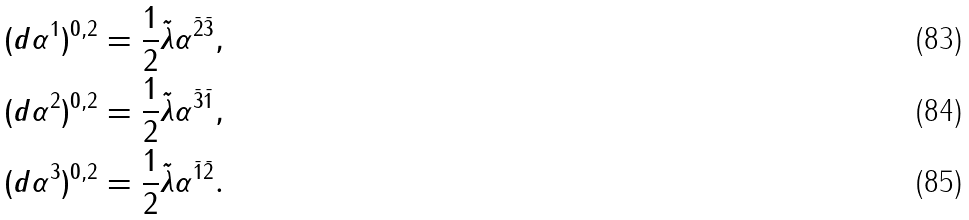<formula> <loc_0><loc_0><loc_500><loc_500>( d \alpha ^ { 1 } ) ^ { 0 , 2 } & = \frac { 1 } { 2 } \tilde { \lambda } \alpha ^ { \bar { 2 } \bar { 3 } } , \\ ( d \alpha ^ { 2 } ) ^ { 0 , 2 } & = \frac { 1 } { 2 } \tilde { \lambda } \alpha ^ { \bar { 3 } \bar { 1 } } , \\ ( d \alpha ^ { 3 } ) ^ { 0 , 2 } & = \frac { 1 } { 2 } \tilde { \lambda } \alpha ^ { \bar { 1 } \bar { 2 } } .</formula> 